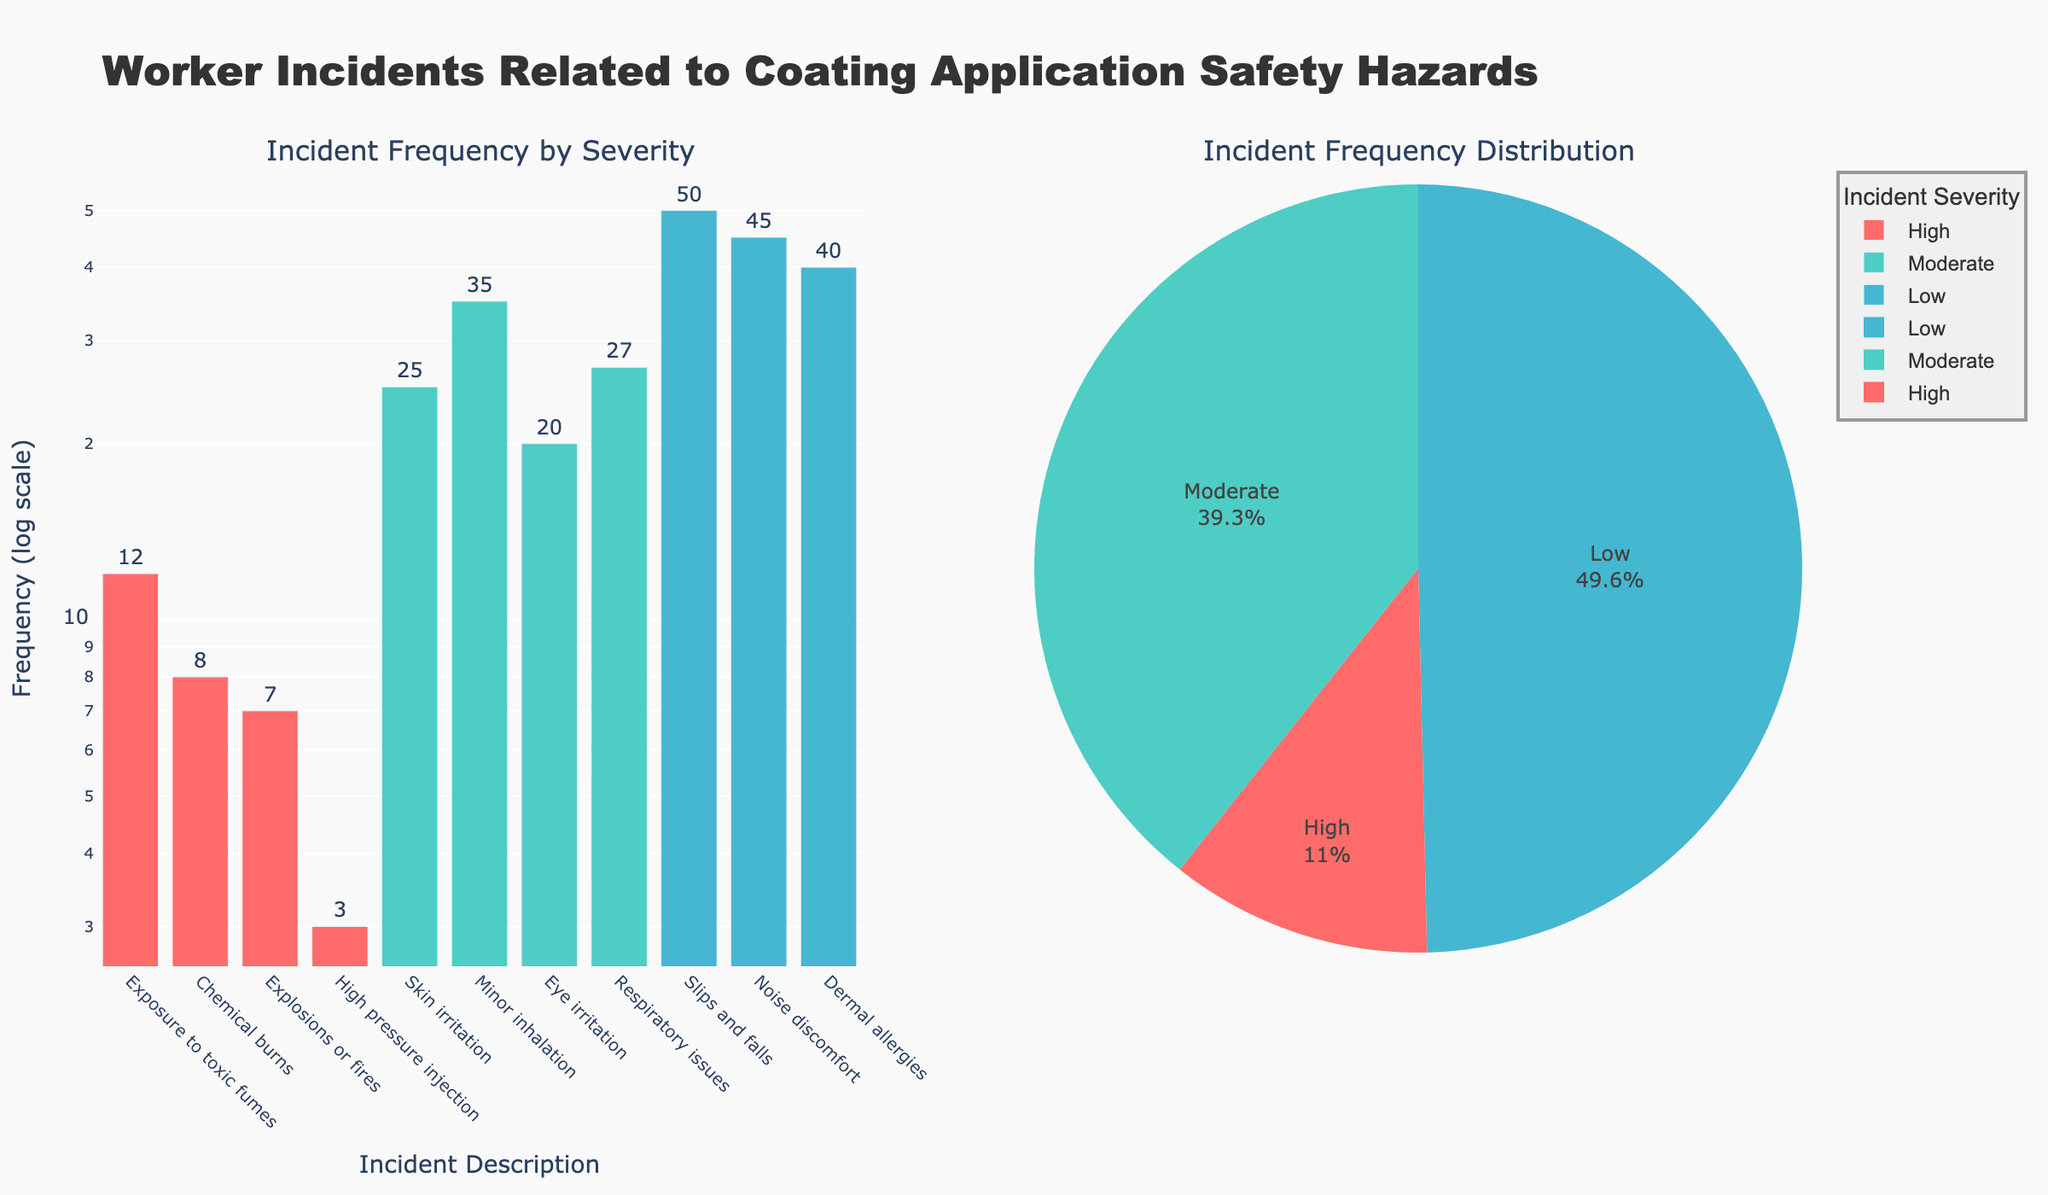What is the title of the bar chart? The title of the bar chart is usually located at the top of the chart and provides a summary of the data being displayed.
Answer: Incident Frequency by Severity What are the three severity levels shown in the pie chart? The pie chart segments represent different severity levels for incidents. The colors and labels denote these categories.
Answer: High, Moderate, Low How many incident types have a high severity? Count the number of unique bars in the bar chart that are colored according to the high severity level.
Answer: 4 Which incident has the highest frequency? Find the bar in the bar chart that reaches the highest point on the log scale y-axis.
Answer: Minor inhalation What is the total frequency of moderate severity incidents? Sum the frequencies of all incidents classified as moderate severity.
Answer: 25 + 35 + 20 + 27 = 107 How does the frequency of skin irritation compare to chemical burns? Compare the height of the bars representing skin irritation and chemical burns in the bar chart.
Answer: Skin irritation is higher What percentage of incidents are of low severity in the pie chart? Look at the pie chart, find the segment marked as low severity, and read the percentage displayed.
Answer: 42.3% Which incident type has the lowest frequency in the high severity category? Identify the bar in the high severity category that has the smallest height.
Answer: High pressure injection What is the combined frequency of exposures to toxic fumes and explosions or fires? Add the frequencies for exposures to toxic fumes and explosions or fires.
Answer: 12 + 7 = 19 Which severity level contributes the most to the total frequency of incidents? Compare the total frequency values for each severity level in the pie chart.
Answer: Low 